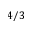Convert formula to latex. <formula><loc_0><loc_0><loc_500><loc_500>4 / 3</formula> 